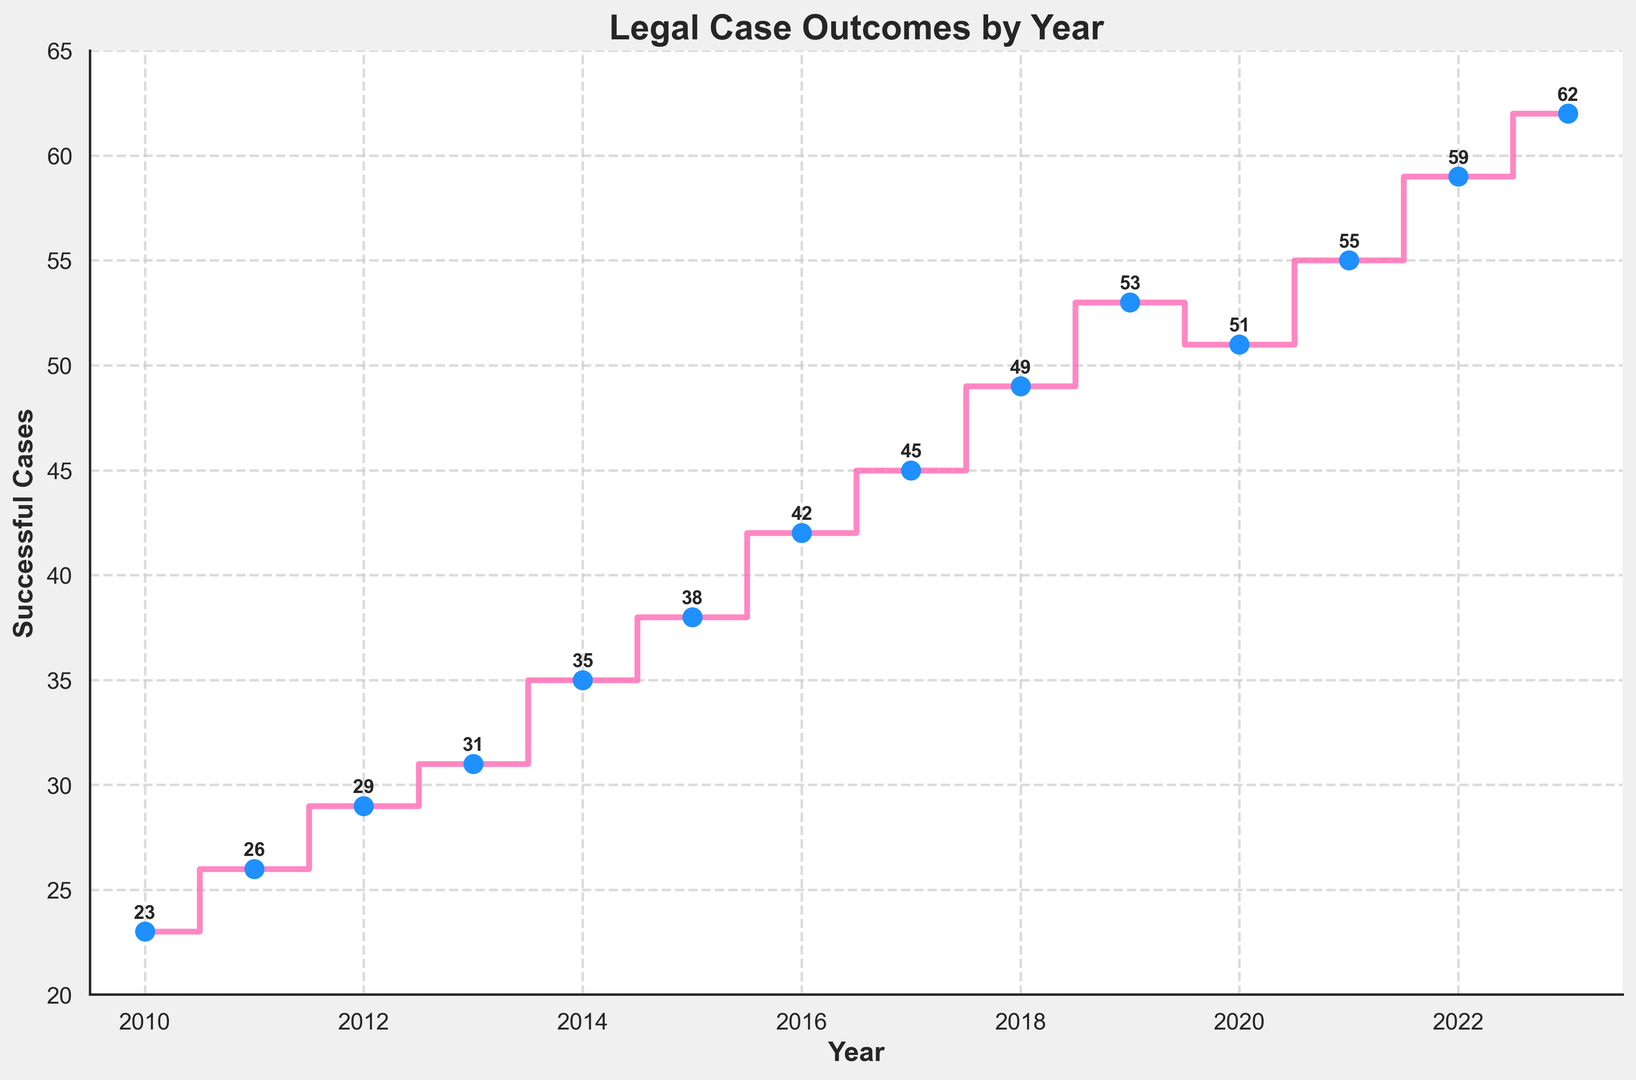What's the trend of successful cases over the years? By looking at the data points from 2010 to 2023, it shows a generally upward trend in the number of successful cases, with small dips, such as between 2019 and 2020.
Answer: Upward trend How many successful cases were there in 2021? Look at the point corresponding to the year 2021 on the x-axis and the associated y-value, which represents the number of successful cases.
Answer: 55 Which year had the highest number of successful cases? Look at the data points and identify the year with the highest y-value.
Answer: 2023 What is the difference in the number of successful cases between 2018 and 2023? Subtract the number of cases in 2018 from the number of cases in 2023 (62 - 49).
Answer: 13 In which year did the number of successful cases decline compared to the previous year? Observe the values from year to year and identify the year where the number decreases. The number declines from 2019 (53) to 2020 (51).
Answer: 2020 How many years have more than 50 successful cases? Count the number of years where the y-axis value is greater than 50. The years are 2019, 2021, 2022 and 2023.
Answer: 4 What is the average number of successful cases from 2010 to 2015? Sum the number of successful cases from 2010 to 2015 and divide by the number of years (23 + 26 + 29 + 31 + 35 + 38 = 182, then 182/6).
Answer: 30.33 Compare the number of successful cases in 2010 and 2023. Which year had fewer cases and by how much? Identify the number of cases in 2010 (23) and in 2023 (62), then subtract the former from the latter (62 - 23).
Answer: 2010 by 39 cases What can be said about the change in the number of successful cases between 2015 and 2016? Look at the data points for these years and identify the change (42 - 38).
Answer: Increase by 4 How does the annotation style contribute to the readability of the figure? Annotations with y-values above each data point in bold and consistent positioning make it easy to read the exact number of cases for each year, enhancing clarity.
Answer: Enhances clarity 